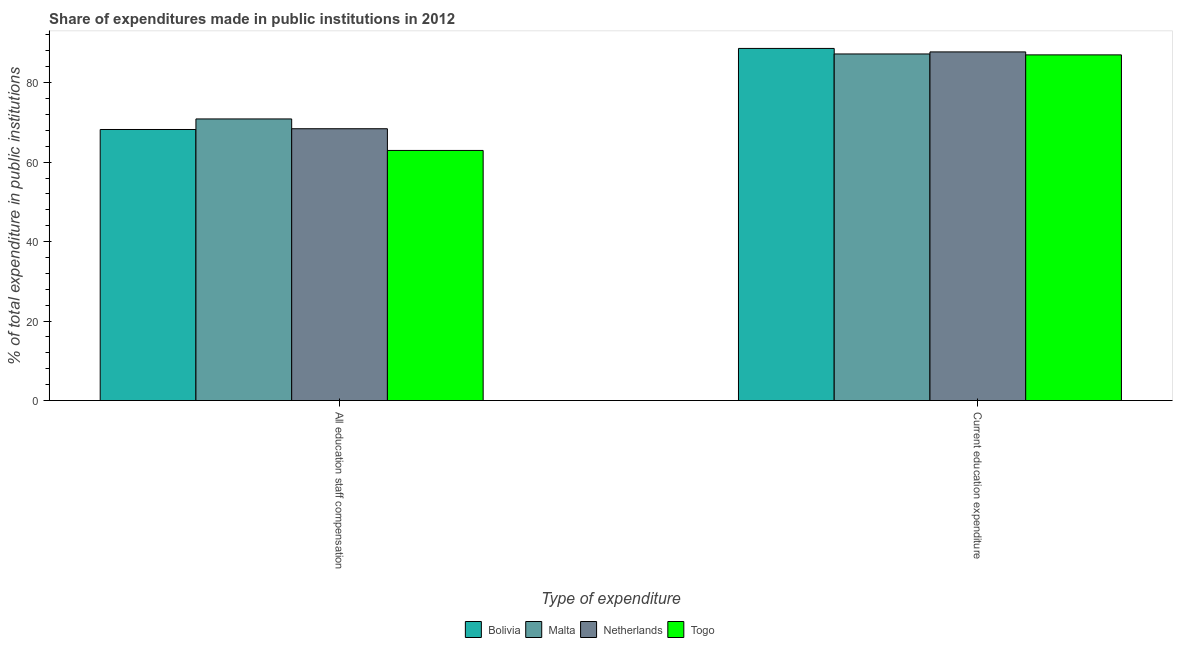How many different coloured bars are there?
Your answer should be very brief. 4. How many bars are there on the 2nd tick from the left?
Make the answer very short. 4. How many bars are there on the 2nd tick from the right?
Give a very brief answer. 4. What is the label of the 2nd group of bars from the left?
Make the answer very short. Current education expenditure. What is the expenditure in education in Bolivia?
Provide a succinct answer. 88.62. Across all countries, what is the maximum expenditure in education?
Make the answer very short. 88.62. Across all countries, what is the minimum expenditure in education?
Make the answer very short. 86.99. In which country was the expenditure in staff compensation maximum?
Provide a short and direct response. Malta. In which country was the expenditure in staff compensation minimum?
Your answer should be compact. Togo. What is the total expenditure in staff compensation in the graph?
Offer a very short reply. 270.44. What is the difference between the expenditure in education in Netherlands and that in Malta?
Ensure brevity in your answer.  0.52. What is the difference between the expenditure in education in Togo and the expenditure in staff compensation in Bolivia?
Give a very brief answer. 18.77. What is the average expenditure in staff compensation per country?
Ensure brevity in your answer.  67.61. What is the difference between the expenditure in staff compensation and expenditure in education in Bolivia?
Provide a succinct answer. -20.4. What is the ratio of the expenditure in education in Malta to that in Netherlands?
Ensure brevity in your answer.  0.99. In how many countries, is the expenditure in staff compensation greater than the average expenditure in staff compensation taken over all countries?
Offer a very short reply. 3. What does the 3rd bar from the left in All education staff compensation represents?
Provide a succinct answer. Netherlands. What does the 1st bar from the right in All education staff compensation represents?
Provide a short and direct response. Togo. Are all the bars in the graph horizontal?
Make the answer very short. No. How many countries are there in the graph?
Your answer should be compact. 4. Does the graph contain any zero values?
Your answer should be very brief. No. Where does the legend appear in the graph?
Keep it short and to the point. Bottom center. How many legend labels are there?
Your answer should be very brief. 4. How are the legend labels stacked?
Offer a very short reply. Horizontal. What is the title of the graph?
Your answer should be very brief. Share of expenditures made in public institutions in 2012. What is the label or title of the X-axis?
Ensure brevity in your answer.  Type of expenditure. What is the label or title of the Y-axis?
Offer a terse response. % of total expenditure in public institutions. What is the % of total expenditure in public institutions in Bolivia in All education staff compensation?
Your answer should be compact. 68.22. What is the % of total expenditure in public institutions of Malta in All education staff compensation?
Keep it short and to the point. 70.87. What is the % of total expenditure in public institutions of Netherlands in All education staff compensation?
Provide a short and direct response. 68.41. What is the % of total expenditure in public institutions of Togo in All education staff compensation?
Keep it short and to the point. 62.94. What is the % of total expenditure in public institutions of Bolivia in Current education expenditure?
Offer a very short reply. 88.62. What is the % of total expenditure in public institutions of Malta in Current education expenditure?
Keep it short and to the point. 87.22. What is the % of total expenditure in public institutions in Netherlands in Current education expenditure?
Offer a terse response. 87.74. What is the % of total expenditure in public institutions in Togo in Current education expenditure?
Keep it short and to the point. 86.99. Across all Type of expenditure, what is the maximum % of total expenditure in public institutions of Bolivia?
Keep it short and to the point. 88.62. Across all Type of expenditure, what is the maximum % of total expenditure in public institutions in Malta?
Your answer should be very brief. 87.22. Across all Type of expenditure, what is the maximum % of total expenditure in public institutions of Netherlands?
Offer a terse response. 87.74. Across all Type of expenditure, what is the maximum % of total expenditure in public institutions in Togo?
Offer a terse response. 86.99. Across all Type of expenditure, what is the minimum % of total expenditure in public institutions of Bolivia?
Your answer should be compact. 68.22. Across all Type of expenditure, what is the minimum % of total expenditure in public institutions in Malta?
Provide a succinct answer. 70.87. Across all Type of expenditure, what is the minimum % of total expenditure in public institutions in Netherlands?
Your answer should be very brief. 68.41. Across all Type of expenditure, what is the minimum % of total expenditure in public institutions in Togo?
Ensure brevity in your answer.  62.94. What is the total % of total expenditure in public institutions of Bolivia in the graph?
Give a very brief answer. 156.83. What is the total % of total expenditure in public institutions of Malta in the graph?
Your answer should be very brief. 158.1. What is the total % of total expenditure in public institutions in Netherlands in the graph?
Offer a very short reply. 156.15. What is the total % of total expenditure in public institutions of Togo in the graph?
Provide a succinct answer. 149.93. What is the difference between the % of total expenditure in public institutions in Bolivia in All education staff compensation and that in Current education expenditure?
Your answer should be compact. -20.4. What is the difference between the % of total expenditure in public institutions of Malta in All education staff compensation and that in Current education expenditure?
Ensure brevity in your answer.  -16.35. What is the difference between the % of total expenditure in public institutions of Netherlands in All education staff compensation and that in Current education expenditure?
Provide a short and direct response. -19.33. What is the difference between the % of total expenditure in public institutions in Togo in All education staff compensation and that in Current education expenditure?
Your answer should be very brief. -24.05. What is the difference between the % of total expenditure in public institutions in Bolivia in All education staff compensation and the % of total expenditure in public institutions in Malta in Current education expenditure?
Your response must be concise. -19.01. What is the difference between the % of total expenditure in public institutions of Bolivia in All education staff compensation and the % of total expenditure in public institutions of Netherlands in Current education expenditure?
Offer a very short reply. -19.52. What is the difference between the % of total expenditure in public institutions in Bolivia in All education staff compensation and the % of total expenditure in public institutions in Togo in Current education expenditure?
Provide a succinct answer. -18.77. What is the difference between the % of total expenditure in public institutions of Malta in All education staff compensation and the % of total expenditure in public institutions of Netherlands in Current education expenditure?
Your answer should be compact. -16.87. What is the difference between the % of total expenditure in public institutions of Malta in All education staff compensation and the % of total expenditure in public institutions of Togo in Current education expenditure?
Your answer should be very brief. -16.12. What is the difference between the % of total expenditure in public institutions of Netherlands in All education staff compensation and the % of total expenditure in public institutions of Togo in Current education expenditure?
Provide a short and direct response. -18.58. What is the average % of total expenditure in public institutions in Bolivia per Type of expenditure?
Your answer should be very brief. 78.42. What is the average % of total expenditure in public institutions of Malta per Type of expenditure?
Your answer should be very brief. 79.05. What is the average % of total expenditure in public institutions in Netherlands per Type of expenditure?
Provide a short and direct response. 78.07. What is the average % of total expenditure in public institutions of Togo per Type of expenditure?
Your response must be concise. 74.97. What is the difference between the % of total expenditure in public institutions of Bolivia and % of total expenditure in public institutions of Malta in All education staff compensation?
Give a very brief answer. -2.66. What is the difference between the % of total expenditure in public institutions of Bolivia and % of total expenditure in public institutions of Netherlands in All education staff compensation?
Give a very brief answer. -0.19. What is the difference between the % of total expenditure in public institutions of Bolivia and % of total expenditure in public institutions of Togo in All education staff compensation?
Give a very brief answer. 5.27. What is the difference between the % of total expenditure in public institutions in Malta and % of total expenditure in public institutions in Netherlands in All education staff compensation?
Offer a very short reply. 2.46. What is the difference between the % of total expenditure in public institutions of Malta and % of total expenditure in public institutions of Togo in All education staff compensation?
Provide a short and direct response. 7.93. What is the difference between the % of total expenditure in public institutions of Netherlands and % of total expenditure in public institutions of Togo in All education staff compensation?
Provide a short and direct response. 5.47. What is the difference between the % of total expenditure in public institutions of Bolivia and % of total expenditure in public institutions of Malta in Current education expenditure?
Your response must be concise. 1.39. What is the difference between the % of total expenditure in public institutions in Bolivia and % of total expenditure in public institutions in Netherlands in Current education expenditure?
Offer a very short reply. 0.88. What is the difference between the % of total expenditure in public institutions of Bolivia and % of total expenditure in public institutions of Togo in Current education expenditure?
Offer a very short reply. 1.63. What is the difference between the % of total expenditure in public institutions of Malta and % of total expenditure in public institutions of Netherlands in Current education expenditure?
Ensure brevity in your answer.  -0.52. What is the difference between the % of total expenditure in public institutions in Malta and % of total expenditure in public institutions in Togo in Current education expenditure?
Offer a very short reply. 0.23. What is the difference between the % of total expenditure in public institutions in Netherlands and % of total expenditure in public institutions in Togo in Current education expenditure?
Make the answer very short. 0.75. What is the ratio of the % of total expenditure in public institutions in Bolivia in All education staff compensation to that in Current education expenditure?
Provide a short and direct response. 0.77. What is the ratio of the % of total expenditure in public institutions in Malta in All education staff compensation to that in Current education expenditure?
Your answer should be compact. 0.81. What is the ratio of the % of total expenditure in public institutions of Netherlands in All education staff compensation to that in Current education expenditure?
Your answer should be compact. 0.78. What is the ratio of the % of total expenditure in public institutions of Togo in All education staff compensation to that in Current education expenditure?
Offer a very short reply. 0.72. What is the difference between the highest and the second highest % of total expenditure in public institutions in Bolivia?
Provide a short and direct response. 20.4. What is the difference between the highest and the second highest % of total expenditure in public institutions in Malta?
Keep it short and to the point. 16.35. What is the difference between the highest and the second highest % of total expenditure in public institutions in Netherlands?
Provide a succinct answer. 19.33. What is the difference between the highest and the second highest % of total expenditure in public institutions of Togo?
Offer a terse response. 24.05. What is the difference between the highest and the lowest % of total expenditure in public institutions in Bolivia?
Keep it short and to the point. 20.4. What is the difference between the highest and the lowest % of total expenditure in public institutions in Malta?
Your answer should be very brief. 16.35. What is the difference between the highest and the lowest % of total expenditure in public institutions in Netherlands?
Your answer should be very brief. 19.33. What is the difference between the highest and the lowest % of total expenditure in public institutions of Togo?
Provide a succinct answer. 24.05. 